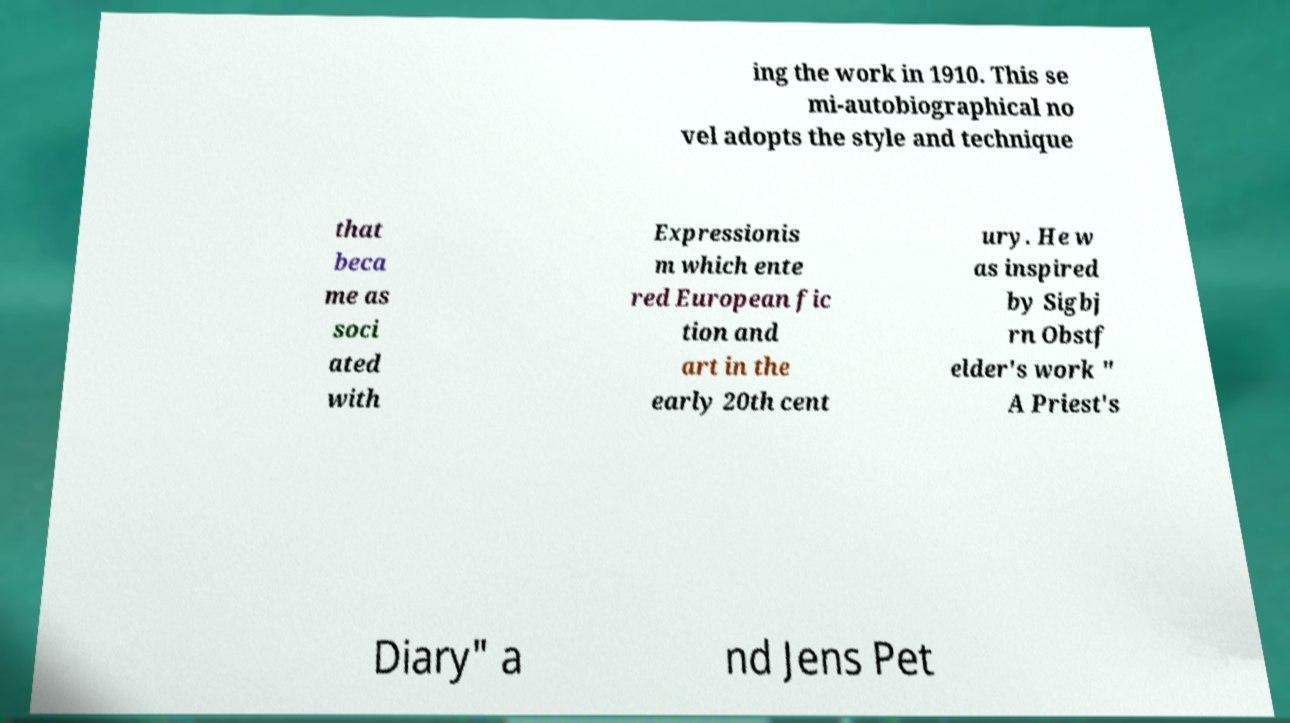Could you extract and type out the text from this image? ing the work in 1910. This se mi-autobiographical no vel adopts the style and technique that beca me as soci ated with Expressionis m which ente red European fic tion and art in the early 20th cent ury. He w as inspired by Sigbj rn Obstf elder's work " A Priest's Diary" a nd Jens Pet 